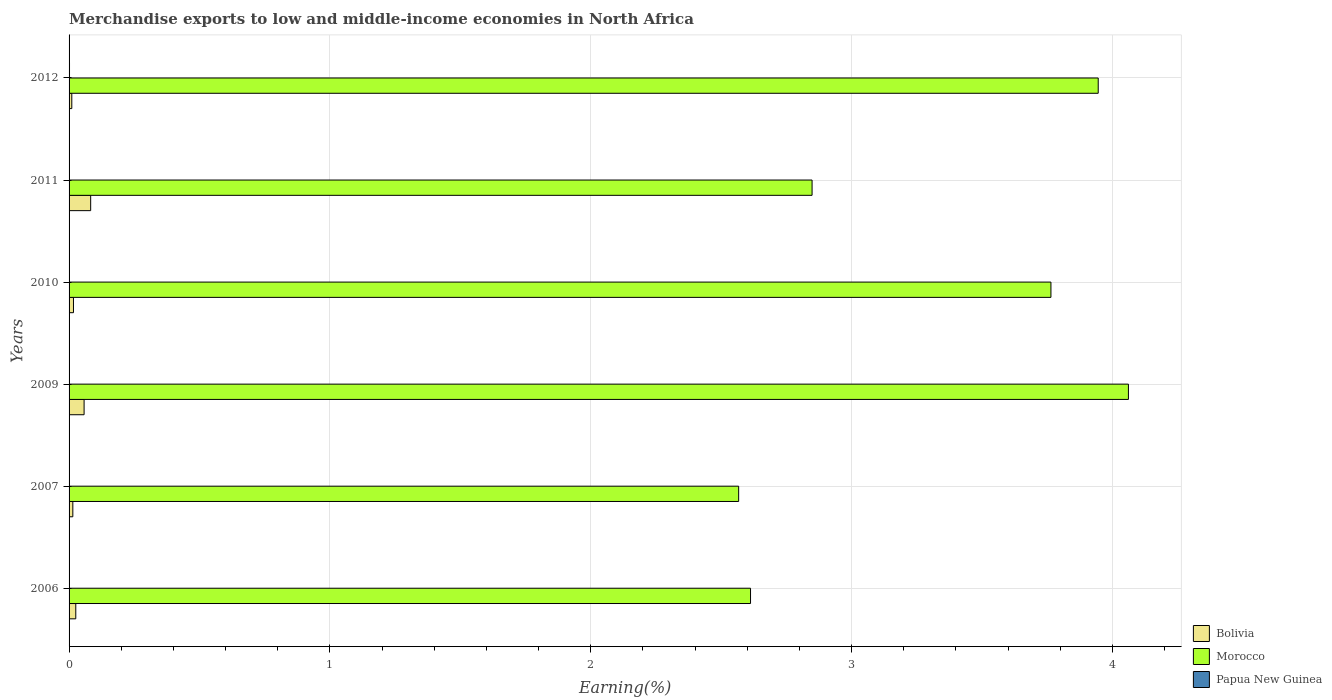How many different coloured bars are there?
Your response must be concise. 3. Are the number of bars on each tick of the Y-axis equal?
Your answer should be compact. Yes. How many bars are there on the 5th tick from the top?
Make the answer very short. 3. How many bars are there on the 1st tick from the bottom?
Provide a short and direct response. 3. What is the label of the 2nd group of bars from the top?
Your response must be concise. 2011. What is the percentage of amount earned from merchandise exports in Bolivia in 2007?
Give a very brief answer. 0.01. Across all years, what is the maximum percentage of amount earned from merchandise exports in Morocco?
Make the answer very short. 4.06. Across all years, what is the minimum percentage of amount earned from merchandise exports in Bolivia?
Offer a terse response. 0.01. In which year was the percentage of amount earned from merchandise exports in Morocco minimum?
Provide a succinct answer. 2007. What is the total percentage of amount earned from merchandise exports in Papua New Guinea in the graph?
Your response must be concise. 0. What is the difference between the percentage of amount earned from merchandise exports in Papua New Guinea in 2007 and that in 2010?
Make the answer very short. 3.133033002307051e-5. What is the difference between the percentage of amount earned from merchandise exports in Papua New Guinea in 2009 and the percentage of amount earned from merchandise exports in Bolivia in 2012?
Your response must be concise. -0.01. What is the average percentage of amount earned from merchandise exports in Papua New Guinea per year?
Offer a very short reply. 0. In the year 2007, what is the difference between the percentage of amount earned from merchandise exports in Bolivia and percentage of amount earned from merchandise exports in Morocco?
Provide a succinct answer. -2.55. What is the ratio of the percentage of amount earned from merchandise exports in Bolivia in 2006 to that in 2010?
Your answer should be compact. 1.53. Is the percentage of amount earned from merchandise exports in Bolivia in 2007 less than that in 2012?
Keep it short and to the point. No. Is the difference between the percentage of amount earned from merchandise exports in Bolivia in 2010 and 2012 greater than the difference between the percentage of amount earned from merchandise exports in Morocco in 2010 and 2012?
Offer a very short reply. Yes. What is the difference between the highest and the second highest percentage of amount earned from merchandise exports in Bolivia?
Make the answer very short. 0.03. What is the difference between the highest and the lowest percentage of amount earned from merchandise exports in Bolivia?
Your response must be concise. 0.07. What does the 2nd bar from the top in 2010 represents?
Offer a terse response. Morocco. What does the 2nd bar from the bottom in 2011 represents?
Keep it short and to the point. Morocco. Are all the bars in the graph horizontal?
Your answer should be compact. Yes. How many years are there in the graph?
Offer a very short reply. 6. Are the values on the major ticks of X-axis written in scientific E-notation?
Your answer should be compact. No. Does the graph contain any zero values?
Your answer should be compact. No. Does the graph contain grids?
Offer a very short reply. Yes. How are the legend labels stacked?
Your answer should be compact. Vertical. What is the title of the graph?
Offer a very short reply. Merchandise exports to low and middle-income economies in North Africa. Does "Sudan" appear as one of the legend labels in the graph?
Offer a terse response. No. What is the label or title of the X-axis?
Your response must be concise. Earning(%). What is the Earning(%) of Bolivia in 2006?
Ensure brevity in your answer.  0.03. What is the Earning(%) of Morocco in 2006?
Your answer should be very brief. 2.61. What is the Earning(%) of Papua New Guinea in 2006?
Make the answer very short. 5.687845223438829e-5. What is the Earning(%) in Bolivia in 2007?
Offer a very short reply. 0.01. What is the Earning(%) in Morocco in 2007?
Provide a short and direct response. 2.57. What is the Earning(%) of Papua New Guinea in 2007?
Give a very brief answer. 7.101729207290841e-5. What is the Earning(%) of Bolivia in 2009?
Give a very brief answer. 0.06. What is the Earning(%) in Morocco in 2009?
Your answer should be compact. 4.06. What is the Earning(%) in Papua New Guinea in 2009?
Your answer should be compact. 2.30290582188182e-5. What is the Earning(%) in Bolivia in 2010?
Provide a succinct answer. 0.02. What is the Earning(%) in Morocco in 2010?
Your response must be concise. 3.76. What is the Earning(%) in Papua New Guinea in 2010?
Offer a very short reply. 3.96869620498379e-5. What is the Earning(%) of Bolivia in 2011?
Offer a terse response. 0.08. What is the Earning(%) of Morocco in 2011?
Your answer should be compact. 2.85. What is the Earning(%) of Papua New Guinea in 2011?
Your response must be concise. 0. What is the Earning(%) in Bolivia in 2012?
Make the answer very short. 0.01. What is the Earning(%) of Morocco in 2012?
Your response must be concise. 3.95. What is the Earning(%) of Papua New Guinea in 2012?
Provide a succinct answer. 0. Across all years, what is the maximum Earning(%) of Bolivia?
Make the answer very short. 0.08. Across all years, what is the maximum Earning(%) in Morocco?
Offer a very short reply. 4.06. Across all years, what is the maximum Earning(%) of Papua New Guinea?
Give a very brief answer. 0. Across all years, what is the minimum Earning(%) in Bolivia?
Ensure brevity in your answer.  0.01. Across all years, what is the minimum Earning(%) of Morocco?
Give a very brief answer. 2.57. Across all years, what is the minimum Earning(%) in Papua New Guinea?
Ensure brevity in your answer.  2.30290582188182e-5. What is the total Earning(%) in Bolivia in the graph?
Provide a short and direct response. 0.21. What is the total Earning(%) in Morocco in the graph?
Provide a succinct answer. 19.8. What is the total Earning(%) in Papua New Guinea in the graph?
Provide a succinct answer. 0. What is the difference between the Earning(%) of Bolivia in 2006 and that in 2007?
Provide a short and direct response. 0.01. What is the difference between the Earning(%) in Morocco in 2006 and that in 2007?
Offer a terse response. 0.05. What is the difference between the Earning(%) in Papua New Guinea in 2006 and that in 2007?
Provide a short and direct response. -0. What is the difference between the Earning(%) in Bolivia in 2006 and that in 2009?
Offer a very short reply. -0.03. What is the difference between the Earning(%) of Morocco in 2006 and that in 2009?
Ensure brevity in your answer.  -1.45. What is the difference between the Earning(%) of Papua New Guinea in 2006 and that in 2009?
Make the answer very short. 0. What is the difference between the Earning(%) in Bolivia in 2006 and that in 2010?
Your answer should be very brief. 0.01. What is the difference between the Earning(%) of Morocco in 2006 and that in 2010?
Make the answer very short. -1.15. What is the difference between the Earning(%) of Papua New Guinea in 2006 and that in 2010?
Offer a very short reply. 0. What is the difference between the Earning(%) of Bolivia in 2006 and that in 2011?
Keep it short and to the point. -0.06. What is the difference between the Earning(%) of Morocco in 2006 and that in 2011?
Provide a succinct answer. -0.24. What is the difference between the Earning(%) of Papua New Guinea in 2006 and that in 2011?
Give a very brief answer. -0. What is the difference between the Earning(%) of Bolivia in 2006 and that in 2012?
Ensure brevity in your answer.  0.02. What is the difference between the Earning(%) in Morocco in 2006 and that in 2012?
Offer a very short reply. -1.33. What is the difference between the Earning(%) of Papua New Guinea in 2006 and that in 2012?
Give a very brief answer. -0. What is the difference between the Earning(%) of Bolivia in 2007 and that in 2009?
Provide a succinct answer. -0.04. What is the difference between the Earning(%) in Morocco in 2007 and that in 2009?
Make the answer very short. -1.49. What is the difference between the Earning(%) in Bolivia in 2007 and that in 2010?
Give a very brief answer. -0. What is the difference between the Earning(%) of Morocco in 2007 and that in 2010?
Give a very brief answer. -1.2. What is the difference between the Earning(%) in Bolivia in 2007 and that in 2011?
Give a very brief answer. -0.07. What is the difference between the Earning(%) in Morocco in 2007 and that in 2011?
Ensure brevity in your answer.  -0.28. What is the difference between the Earning(%) in Papua New Guinea in 2007 and that in 2011?
Your answer should be compact. -0. What is the difference between the Earning(%) in Bolivia in 2007 and that in 2012?
Keep it short and to the point. 0. What is the difference between the Earning(%) of Morocco in 2007 and that in 2012?
Offer a terse response. -1.38. What is the difference between the Earning(%) of Papua New Guinea in 2007 and that in 2012?
Make the answer very short. -0. What is the difference between the Earning(%) in Bolivia in 2009 and that in 2010?
Provide a succinct answer. 0.04. What is the difference between the Earning(%) in Morocco in 2009 and that in 2010?
Ensure brevity in your answer.  0.3. What is the difference between the Earning(%) in Papua New Guinea in 2009 and that in 2010?
Your answer should be compact. -0. What is the difference between the Earning(%) of Bolivia in 2009 and that in 2011?
Your response must be concise. -0.03. What is the difference between the Earning(%) in Morocco in 2009 and that in 2011?
Your answer should be very brief. 1.21. What is the difference between the Earning(%) in Papua New Guinea in 2009 and that in 2011?
Your answer should be compact. -0. What is the difference between the Earning(%) in Bolivia in 2009 and that in 2012?
Provide a succinct answer. 0.05. What is the difference between the Earning(%) in Morocco in 2009 and that in 2012?
Provide a short and direct response. 0.12. What is the difference between the Earning(%) of Papua New Guinea in 2009 and that in 2012?
Your answer should be very brief. -0. What is the difference between the Earning(%) in Bolivia in 2010 and that in 2011?
Provide a short and direct response. -0.07. What is the difference between the Earning(%) of Morocco in 2010 and that in 2011?
Your answer should be very brief. 0.92. What is the difference between the Earning(%) of Papua New Guinea in 2010 and that in 2011?
Make the answer very short. -0. What is the difference between the Earning(%) in Bolivia in 2010 and that in 2012?
Ensure brevity in your answer.  0.01. What is the difference between the Earning(%) of Morocco in 2010 and that in 2012?
Offer a terse response. -0.18. What is the difference between the Earning(%) of Papua New Guinea in 2010 and that in 2012?
Offer a terse response. -0. What is the difference between the Earning(%) in Bolivia in 2011 and that in 2012?
Provide a succinct answer. 0.07. What is the difference between the Earning(%) of Morocco in 2011 and that in 2012?
Offer a very short reply. -1.1. What is the difference between the Earning(%) of Papua New Guinea in 2011 and that in 2012?
Offer a very short reply. -0. What is the difference between the Earning(%) of Bolivia in 2006 and the Earning(%) of Morocco in 2007?
Keep it short and to the point. -2.54. What is the difference between the Earning(%) in Bolivia in 2006 and the Earning(%) in Papua New Guinea in 2007?
Provide a succinct answer. 0.03. What is the difference between the Earning(%) in Morocco in 2006 and the Earning(%) in Papua New Guinea in 2007?
Your response must be concise. 2.61. What is the difference between the Earning(%) of Bolivia in 2006 and the Earning(%) of Morocco in 2009?
Offer a terse response. -4.04. What is the difference between the Earning(%) of Bolivia in 2006 and the Earning(%) of Papua New Guinea in 2009?
Ensure brevity in your answer.  0.03. What is the difference between the Earning(%) of Morocco in 2006 and the Earning(%) of Papua New Guinea in 2009?
Offer a terse response. 2.61. What is the difference between the Earning(%) in Bolivia in 2006 and the Earning(%) in Morocco in 2010?
Offer a very short reply. -3.74. What is the difference between the Earning(%) in Bolivia in 2006 and the Earning(%) in Papua New Guinea in 2010?
Your response must be concise. 0.03. What is the difference between the Earning(%) of Morocco in 2006 and the Earning(%) of Papua New Guinea in 2010?
Keep it short and to the point. 2.61. What is the difference between the Earning(%) in Bolivia in 2006 and the Earning(%) in Morocco in 2011?
Offer a very short reply. -2.82. What is the difference between the Earning(%) in Bolivia in 2006 and the Earning(%) in Papua New Guinea in 2011?
Your response must be concise. 0.02. What is the difference between the Earning(%) in Morocco in 2006 and the Earning(%) in Papua New Guinea in 2011?
Offer a very short reply. 2.61. What is the difference between the Earning(%) in Bolivia in 2006 and the Earning(%) in Morocco in 2012?
Keep it short and to the point. -3.92. What is the difference between the Earning(%) in Bolivia in 2006 and the Earning(%) in Papua New Guinea in 2012?
Your answer should be compact. 0.02. What is the difference between the Earning(%) of Morocco in 2006 and the Earning(%) of Papua New Guinea in 2012?
Ensure brevity in your answer.  2.61. What is the difference between the Earning(%) in Bolivia in 2007 and the Earning(%) in Morocco in 2009?
Ensure brevity in your answer.  -4.05. What is the difference between the Earning(%) in Bolivia in 2007 and the Earning(%) in Papua New Guinea in 2009?
Your answer should be compact. 0.01. What is the difference between the Earning(%) in Morocco in 2007 and the Earning(%) in Papua New Guinea in 2009?
Ensure brevity in your answer.  2.57. What is the difference between the Earning(%) of Bolivia in 2007 and the Earning(%) of Morocco in 2010?
Your response must be concise. -3.75. What is the difference between the Earning(%) of Bolivia in 2007 and the Earning(%) of Papua New Guinea in 2010?
Keep it short and to the point. 0.01. What is the difference between the Earning(%) in Morocco in 2007 and the Earning(%) in Papua New Guinea in 2010?
Ensure brevity in your answer.  2.57. What is the difference between the Earning(%) in Bolivia in 2007 and the Earning(%) in Morocco in 2011?
Offer a very short reply. -2.83. What is the difference between the Earning(%) of Bolivia in 2007 and the Earning(%) of Papua New Guinea in 2011?
Provide a short and direct response. 0.01. What is the difference between the Earning(%) of Morocco in 2007 and the Earning(%) of Papua New Guinea in 2011?
Provide a succinct answer. 2.57. What is the difference between the Earning(%) in Bolivia in 2007 and the Earning(%) in Morocco in 2012?
Your response must be concise. -3.93. What is the difference between the Earning(%) of Bolivia in 2007 and the Earning(%) of Papua New Guinea in 2012?
Keep it short and to the point. 0.01. What is the difference between the Earning(%) in Morocco in 2007 and the Earning(%) in Papua New Guinea in 2012?
Your answer should be compact. 2.57. What is the difference between the Earning(%) of Bolivia in 2009 and the Earning(%) of Morocco in 2010?
Your response must be concise. -3.71. What is the difference between the Earning(%) in Bolivia in 2009 and the Earning(%) in Papua New Guinea in 2010?
Your answer should be very brief. 0.06. What is the difference between the Earning(%) of Morocco in 2009 and the Earning(%) of Papua New Guinea in 2010?
Your answer should be very brief. 4.06. What is the difference between the Earning(%) of Bolivia in 2009 and the Earning(%) of Morocco in 2011?
Offer a very short reply. -2.79. What is the difference between the Earning(%) of Bolivia in 2009 and the Earning(%) of Papua New Guinea in 2011?
Your answer should be very brief. 0.06. What is the difference between the Earning(%) in Morocco in 2009 and the Earning(%) in Papua New Guinea in 2011?
Make the answer very short. 4.06. What is the difference between the Earning(%) in Bolivia in 2009 and the Earning(%) in Morocco in 2012?
Offer a very short reply. -3.89. What is the difference between the Earning(%) in Bolivia in 2009 and the Earning(%) in Papua New Guinea in 2012?
Offer a very short reply. 0.06. What is the difference between the Earning(%) in Morocco in 2009 and the Earning(%) in Papua New Guinea in 2012?
Provide a short and direct response. 4.06. What is the difference between the Earning(%) of Bolivia in 2010 and the Earning(%) of Morocco in 2011?
Your response must be concise. -2.83. What is the difference between the Earning(%) in Bolivia in 2010 and the Earning(%) in Papua New Guinea in 2011?
Your answer should be compact. 0.02. What is the difference between the Earning(%) in Morocco in 2010 and the Earning(%) in Papua New Guinea in 2011?
Your response must be concise. 3.76. What is the difference between the Earning(%) in Bolivia in 2010 and the Earning(%) in Morocco in 2012?
Offer a very short reply. -3.93. What is the difference between the Earning(%) in Bolivia in 2010 and the Earning(%) in Papua New Guinea in 2012?
Your answer should be compact. 0.02. What is the difference between the Earning(%) of Morocco in 2010 and the Earning(%) of Papua New Guinea in 2012?
Your answer should be very brief. 3.76. What is the difference between the Earning(%) of Bolivia in 2011 and the Earning(%) of Morocco in 2012?
Make the answer very short. -3.86. What is the difference between the Earning(%) of Bolivia in 2011 and the Earning(%) of Papua New Guinea in 2012?
Keep it short and to the point. 0.08. What is the difference between the Earning(%) of Morocco in 2011 and the Earning(%) of Papua New Guinea in 2012?
Offer a very short reply. 2.85. What is the average Earning(%) of Bolivia per year?
Make the answer very short. 0.03. What is the average Earning(%) of Morocco per year?
Your answer should be compact. 3.3. What is the average Earning(%) of Papua New Guinea per year?
Your answer should be compact. 0. In the year 2006, what is the difference between the Earning(%) of Bolivia and Earning(%) of Morocco?
Your answer should be very brief. -2.59. In the year 2006, what is the difference between the Earning(%) of Bolivia and Earning(%) of Papua New Guinea?
Your response must be concise. 0.03. In the year 2006, what is the difference between the Earning(%) in Morocco and Earning(%) in Papua New Guinea?
Your response must be concise. 2.61. In the year 2007, what is the difference between the Earning(%) of Bolivia and Earning(%) of Morocco?
Your answer should be very brief. -2.55. In the year 2007, what is the difference between the Earning(%) in Bolivia and Earning(%) in Papua New Guinea?
Provide a short and direct response. 0.01. In the year 2007, what is the difference between the Earning(%) in Morocco and Earning(%) in Papua New Guinea?
Your answer should be very brief. 2.57. In the year 2009, what is the difference between the Earning(%) of Bolivia and Earning(%) of Morocco?
Your answer should be compact. -4. In the year 2009, what is the difference between the Earning(%) in Bolivia and Earning(%) in Papua New Guinea?
Make the answer very short. 0.06. In the year 2009, what is the difference between the Earning(%) of Morocco and Earning(%) of Papua New Guinea?
Keep it short and to the point. 4.06. In the year 2010, what is the difference between the Earning(%) in Bolivia and Earning(%) in Morocco?
Make the answer very short. -3.75. In the year 2010, what is the difference between the Earning(%) in Bolivia and Earning(%) in Papua New Guinea?
Your answer should be compact. 0.02. In the year 2010, what is the difference between the Earning(%) of Morocco and Earning(%) of Papua New Guinea?
Your answer should be very brief. 3.76. In the year 2011, what is the difference between the Earning(%) in Bolivia and Earning(%) in Morocco?
Offer a very short reply. -2.77. In the year 2011, what is the difference between the Earning(%) in Bolivia and Earning(%) in Papua New Guinea?
Ensure brevity in your answer.  0.08. In the year 2011, what is the difference between the Earning(%) in Morocco and Earning(%) in Papua New Guinea?
Ensure brevity in your answer.  2.85. In the year 2012, what is the difference between the Earning(%) of Bolivia and Earning(%) of Morocco?
Give a very brief answer. -3.94. In the year 2012, what is the difference between the Earning(%) of Bolivia and Earning(%) of Papua New Guinea?
Your response must be concise. 0.01. In the year 2012, what is the difference between the Earning(%) in Morocco and Earning(%) in Papua New Guinea?
Provide a succinct answer. 3.94. What is the ratio of the Earning(%) of Bolivia in 2006 to that in 2007?
Keep it short and to the point. 1.79. What is the ratio of the Earning(%) of Morocco in 2006 to that in 2007?
Your response must be concise. 1.02. What is the ratio of the Earning(%) in Papua New Guinea in 2006 to that in 2007?
Give a very brief answer. 0.8. What is the ratio of the Earning(%) of Bolivia in 2006 to that in 2009?
Provide a succinct answer. 0.45. What is the ratio of the Earning(%) of Morocco in 2006 to that in 2009?
Your answer should be very brief. 0.64. What is the ratio of the Earning(%) in Papua New Guinea in 2006 to that in 2009?
Offer a very short reply. 2.47. What is the ratio of the Earning(%) of Bolivia in 2006 to that in 2010?
Make the answer very short. 1.53. What is the ratio of the Earning(%) of Morocco in 2006 to that in 2010?
Your answer should be very brief. 0.69. What is the ratio of the Earning(%) of Papua New Guinea in 2006 to that in 2010?
Give a very brief answer. 1.43. What is the ratio of the Earning(%) of Bolivia in 2006 to that in 2011?
Your answer should be very brief. 0.31. What is the ratio of the Earning(%) in Morocco in 2006 to that in 2011?
Your answer should be very brief. 0.92. What is the ratio of the Earning(%) of Papua New Guinea in 2006 to that in 2011?
Make the answer very short. 0.04. What is the ratio of the Earning(%) in Bolivia in 2006 to that in 2012?
Give a very brief answer. 2.46. What is the ratio of the Earning(%) of Morocco in 2006 to that in 2012?
Provide a succinct answer. 0.66. What is the ratio of the Earning(%) in Papua New Guinea in 2006 to that in 2012?
Offer a very short reply. 0.03. What is the ratio of the Earning(%) in Morocco in 2007 to that in 2009?
Keep it short and to the point. 0.63. What is the ratio of the Earning(%) in Papua New Guinea in 2007 to that in 2009?
Offer a very short reply. 3.08. What is the ratio of the Earning(%) in Bolivia in 2007 to that in 2010?
Provide a short and direct response. 0.86. What is the ratio of the Earning(%) of Morocco in 2007 to that in 2010?
Give a very brief answer. 0.68. What is the ratio of the Earning(%) of Papua New Guinea in 2007 to that in 2010?
Ensure brevity in your answer.  1.79. What is the ratio of the Earning(%) in Bolivia in 2007 to that in 2011?
Offer a terse response. 0.17. What is the ratio of the Earning(%) in Morocco in 2007 to that in 2011?
Keep it short and to the point. 0.9. What is the ratio of the Earning(%) of Papua New Guinea in 2007 to that in 2011?
Your answer should be compact. 0.05. What is the ratio of the Earning(%) in Bolivia in 2007 to that in 2012?
Your response must be concise. 1.38. What is the ratio of the Earning(%) of Morocco in 2007 to that in 2012?
Give a very brief answer. 0.65. What is the ratio of the Earning(%) of Papua New Guinea in 2007 to that in 2012?
Your response must be concise. 0.04. What is the ratio of the Earning(%) of Bolivia in 2009 to that in 2010?
Ensure brevity in your answer.  3.42. What is the ratio of the Earning(%) of Morocco in 2009 to that in 2010?
Keep it short and to the point. 1.08. What is the ratio of the Earning(%) of Papua New Guinea in 2009 to that in 2010?
Offer a very short reply. 0.58. What is the ratio of the Earning(%) in Bolivia in 2009 to that in 2011?
Your answer should be compact. 0.7. What is the ratio of the Earning(%) in Morocco in 2009 to that in 2011?
Offer a very short reply. 1.43. What is the ratio of the Earning(%) of Papua New Guinea in 2009 to that in 2011?
Give a very brief answer. 0.02. What is the ratio of the Earning(%) of Bolivia in 2009 to that in 2012?
Ensure brevity in your answer.  5.5. What is the ratio of the Earning(%) of Morocco in 2009 to that in 2012?
Give a very brief answer. 1.03. What is the ratio of the Earning(%) of Papua New Guinea in 2009 to that in 2012?
Make the answer very short. 0.01. What is the ratio of the Earning(%) in Bolivia in 2010 to that in 2011?
Keep it short and to the point. 0.2. What is the ratio of the Earning(%) of Morocco in 2010 to that in 2011?
Offer a very short reply. 1.32. What is the ratio of the Earning(%) of Papua New Guinea in 2010 to that in 2011?
Offer a very short reply. 0.03. What is the ratio of the Earning(%) in Bolivia in 2010 to that in 2012?
Give a very brief answer. 1.61. What is the ratio of the Earning(%) of Morocco in 2010 to that in 2012?
Offer a very short reply. 0.95. What is the ratio of the Earning(%) in Papua New Guinea in 2010 to that in 2012?
Give a very brief answer. 0.02. What is the ratio of the Earning(%) of Bolivia in 2011 to that in 2012?
Your answer should be very brief. 7.91. What is the ratio of the Earning(%) of Morocco in 2011 to that in 2012?
Provide a short and direct response. 0.72. What is the ratio of the Earning(%) of Papua New Guinea in 2011 to that in 2012?
Provide a short and direct response. 0.85. What is the difference between the highest and the second highest Earning(%) of Bolivia?
Your answer should be compact. 0.03. What is the difference between the highest and the second highest Earning(%) of Morocco?
Your answer should be compact. 0.12. What is the difference between the highest and the lowest Earning(%) of Bolivia?
Your response must be concise. 0.07. What is the difference between the highest and the lowest Earning(%) in Morocco?
Provide a succinct answer. 1.49. What is the difference between the highest and the lowest Earning(%) of Papua New Guinea?
Offer a terse response. 0. 